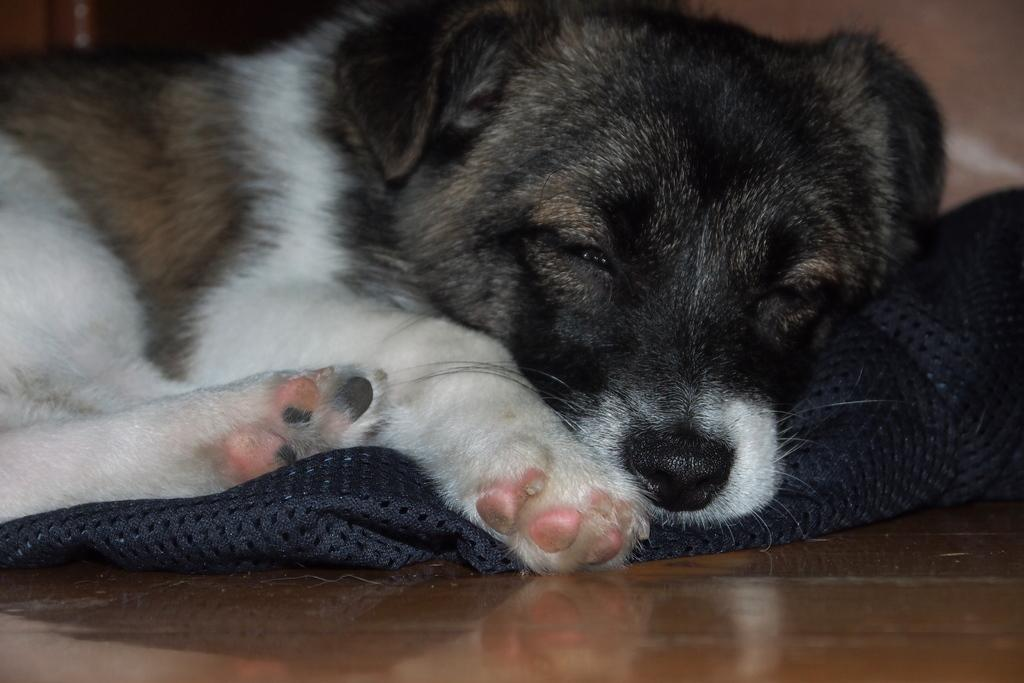What type of animal can be seen in the image? There is a dog in the image. What is the color scheme of the image? The image is in black and white. What is on the floor in the image? There is a mat on the floor in the image. What is the dog doing in the image? The dog is sleeping. Where is the guitar located in the image? There is no guitar present in the image. Can you see a nest in the image? There is no nest present in the image. 